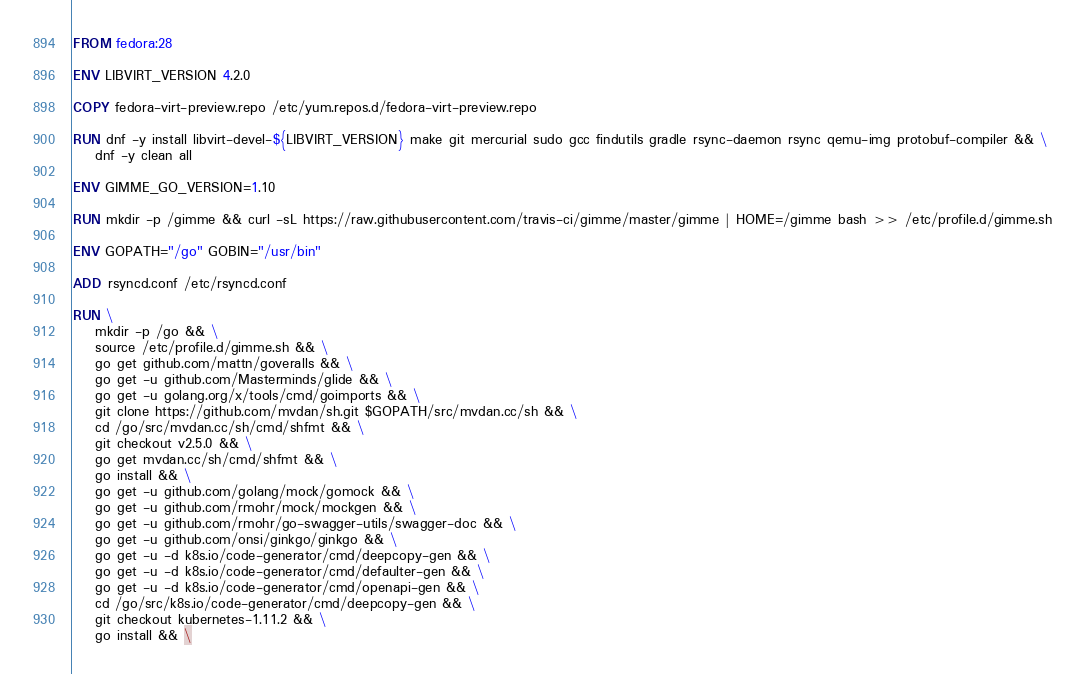Convert code to text. <code><loc_0><loc_0><loc_500><loc_500><_Dockerfile_>FROM fedora:28

ENV LIBVIRT_VERSION 4.2.0

COPY fedora-virt-preview.repo /etc/yum.repos.d/fedora-virt-preview.repo

RUN dnf -y install libvirt-devel-${LIBVIRT_VERSION} make git mercurial sudo gcc findutils gradle rsync-daemon rsync qemu-img protobuf-compiler && \
    dnf -y clean all

ENV GIMME_GO_VERSION=1.10

RUN mkdir -p /gimme && curl -sL https://raw.githubusercontent.com/travis-ci/gimme/master/gimme | HOME=/gimme bash >> /etc/profile.d/gimme.sh

ENV GOPATH="/go" GOBIN="/usr/bin"

ADD rsyncd.conf /etc/rsyncd.conf

RUN \
    mkdir -p /go && \
    source /etc/profile.d/gimme.sh && \
    go get github.com/mattn/goveralls && \
    go get -u github.com/Masterminds/glide && \
    go get -u golang.org/x/tools/cmd/goimports && \
    git clone https://github.com/mvdan/sh.git $GOPATH/src/mvdan.cc/sh && \
    cd /go/src/mvdan.cc/sh/cmd/shfmt && \
    git checkout v2.5.0 && \
    go get mvdan.cc/sh/cmd/shfmt && \
    go install && \
    go get -u github.com/golang/mock/gomock && \
    go get -u github.com/rmohr/mock/mockgen && \
    go get -u github.com/rmohr/go-swagger-utils/swagger-doc && \
    go get -u github.com/onsi/ginkgo/ginkgo && \
    go get -u -d k8s.io/code-generator/cmd/deepcopy-gen && \
    go get -u -d k8s.io/code-generator/cmd/defaulter-gen && \
    go get -u -d k8s.io/code-generator/cmd/openapi-gen && \
    cd /go/src/k8s.io/code-generator/cmd/deepcopy-gen && \
    git checkout kubernetes-1.11.2 && \
    go install && \</code> 